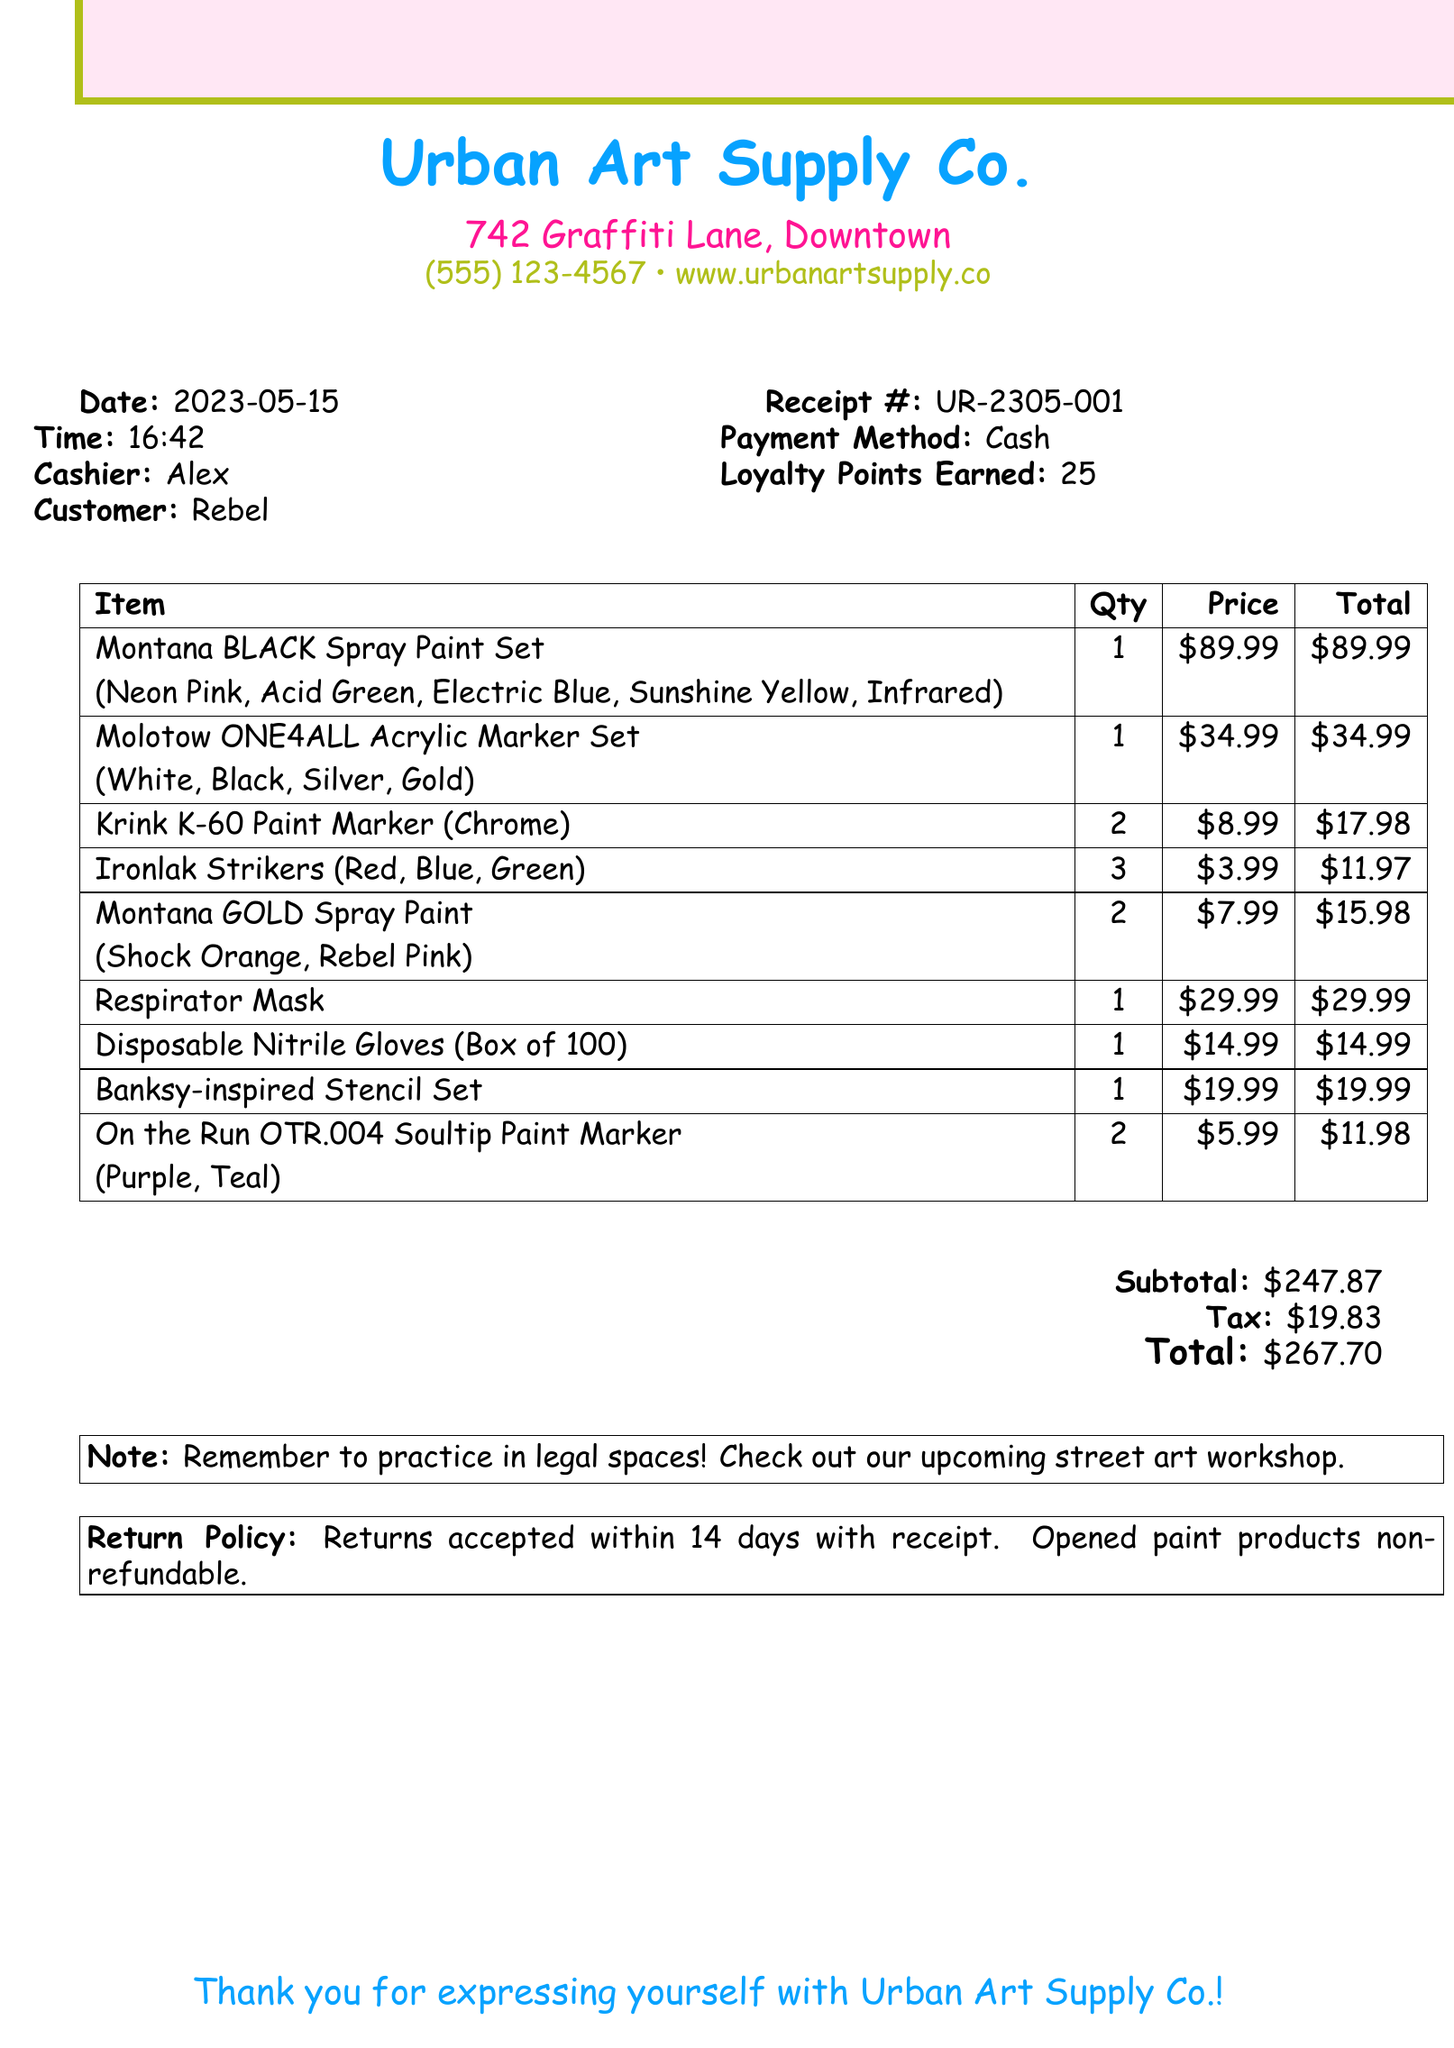What is the store name? The store name is listed at the top of the receipt.
Answer: Urban Art Supply Co What is the total amount spent? The total amount is provided at the bottom of the receipt.
Answer: $267.70 How many items were purchased in total? The number of items can be counted from the list provided in the document.
Answer: 10 Who was the cashier? The cashier's name is explicitly stated in the document.
Answer: Alex What colors are included in the Montana BLACK Spray Paint Set? The colors are listed next to the specific item in the receipt.
Answer: Neon Pink, Acid Green, Electric Blue, Sunshine Yellow, Infrared What is the date of purchase? The date of purchase is noted near the top of the receipt.
Answer: 2023-05-15 What is the return policy? The return policy is summarized in a box towards the end of the document.
Answer: Returns accepted within 14 days with receipt. Opened paint products non-refundable How many loyalty points were earned? The loyalty points are indicated in the payment section of the receipt.
Answer: 25 What was the quantity of Ironlak Strikers purchased? The quantity is specified in the items list on the receipt.
Answer: 3 